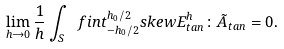Convert formula to latex. <formula><loc_0><loc_0><loc_500><loc_500>\lim _ { h \to 0 } \frac { 1 } { h } \int _ { S } \ f i n t _ { - h _ { 0 } / 2 } ^ { h _ { 0 } / 2 } s k e w E ^ { h } _ { t a n } \colon \tilde { A } _ { t a n } = 0 .</formula> 